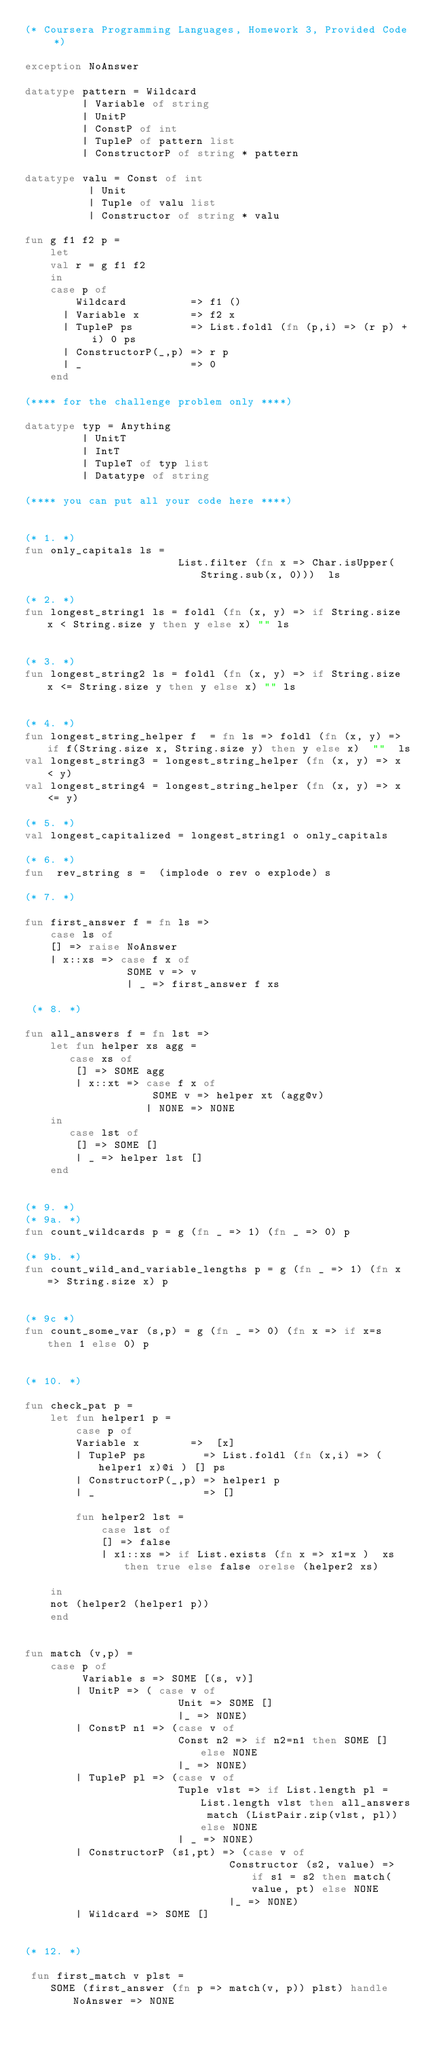Convert code to text. <code><loc_0><loc_0><loc_500><loc_500><_SML_>(* Coursera Programming Languages, Homework 3, Provided Code *)

exception NoAnswer

datatype pattern = Wildcard
		 | Variable of string
		 | UnitP
		 | ConstP of int
		 | TupleP of pattern list
		 | ConstructorP of string * pattern

datatype valu = Const of int
	      | Unit
	      | Tuple of valu list
	      | Constructor of string * valu

fun g f1 f2 p =
    let 
	val r = g f1 f2 
    in
	case p of
	    Wildcard          => f1 ()
	  | Variable x        => f2 x
	  | TupleP ps         => List.foldl (fn (p,i) => (r p) + i) 0 ps
	  | ConstructorP(_,p) => r p
	  | _                 => 0
    end

(**** for the challenge problem only ****)

datatype typ = Anything
	     | UnitT
	     | IntT
	     | TupleT of typ list
	     | Datatype of string

(**** you can put all your code here ****)


(* 1. *)
fun only_capitals ls = 
                        List.filter (fn x => Char.isUpper(String.sub(x, 0)))  ls

(* 2. *)
fun longest_string1 ls = foldl (fn (x, y) => if String.size x < String.size y then y else x) "" ls


(* 3. *)
fun longest_string2 ls = foldl (fn (x, y) => if String.size x <= String.size y then y else x) "" ls


(* 4. *)
fun longest_string_helper f  = fn ls => foldl (fn (x, y) => if f(String.size x, String.size y) then y else x)  ""  ls 
val longest_string3 = longest_string_helper (fn (x, y) => x < y)
val longest_string4 = longest_string_helper (fn (x, y) => x <= y)

(* 5. *)
val longest_capitalized = longest_string1 o only_capitals

(* 6. *)
fun  rev_string s =  (implode o rev o explode) s

(* 7. *)

fun first_answer f = fn ls => 
    case ls of
    [] => raise NoAnswer
    | x::xs => case f x of
                SOME v => v 
                | _ => first_answer f xs
            
 (* 8. *)

fun all_answers f = fn lst =>
    let fun helper xs agg =
       case xs of
        [] => SOME agg 
        | x::xt => case f x of
                    SOME v => helper xt (agg@v)
                   | NONE => NONE
    in  
       case lst of
        [] => SOME []
        | _ => helper lst []
    end


(* 9. *)
(* 9a. *)
fun count_wildcards p = g (fn _ => 1) (fn _ => 0) p

(* 9b. *)
fun count_wild_and_variable_lengths p = g (fn _ => 1) (fn x => String.size x) p


(* 9c *)
fun count_some_var (s,p) = g (fn _ => 0) (fn x => if x=s then 1 else 0) p 


(* 10. *)

fun check_pat p = 
    let fun helper1 p =
        case p of
        Variable x        =>  [x]
        | TupleP ps         => List.foldl (fn (x,i) => (helper1 x)@i ) [] ps
        | ConstructorP(_,p) => helper1 p
        | _                 => []

        fun helper2 lst =
            case lst of
            [] => false
            | x1::xs => if List.exists (fn x => x1=x )  xs  then true else false orelse (helper2 xs)

    in
    not (helper2 (helper1 p))
    end
    

fun match (v,p) = 
    case p of
		 Variable s => SOME [(s, v)]
		| UnitP => ( case v of 
                        Unit => SOME []
                        |_ => NONE)
		| ConstP n1 => (case v of 
                        Const n2 => if n2=n1 then SOME [] else NONE
                        |_ => NONE)
		| TupleP pl => (case v of
                        Tuple vlst => if List.length pl = List.length vlst then all_answers match (ListPair.zip(vlst, pl)) else NONE
                        | _ => NONE)
		| ConstructorP (s1,pt) => (case v of 
                                Constructor (s2, value) => if s1 = s2 then match(value, pt) else NONE
                                |_ => NONE)
        | Wildcard => SOME []


(* 12. *)

 fun first_match v plst =
    SOME (first_answer (fn p => match(v, p)) plst) handle NoAnswer => NONE </code> 